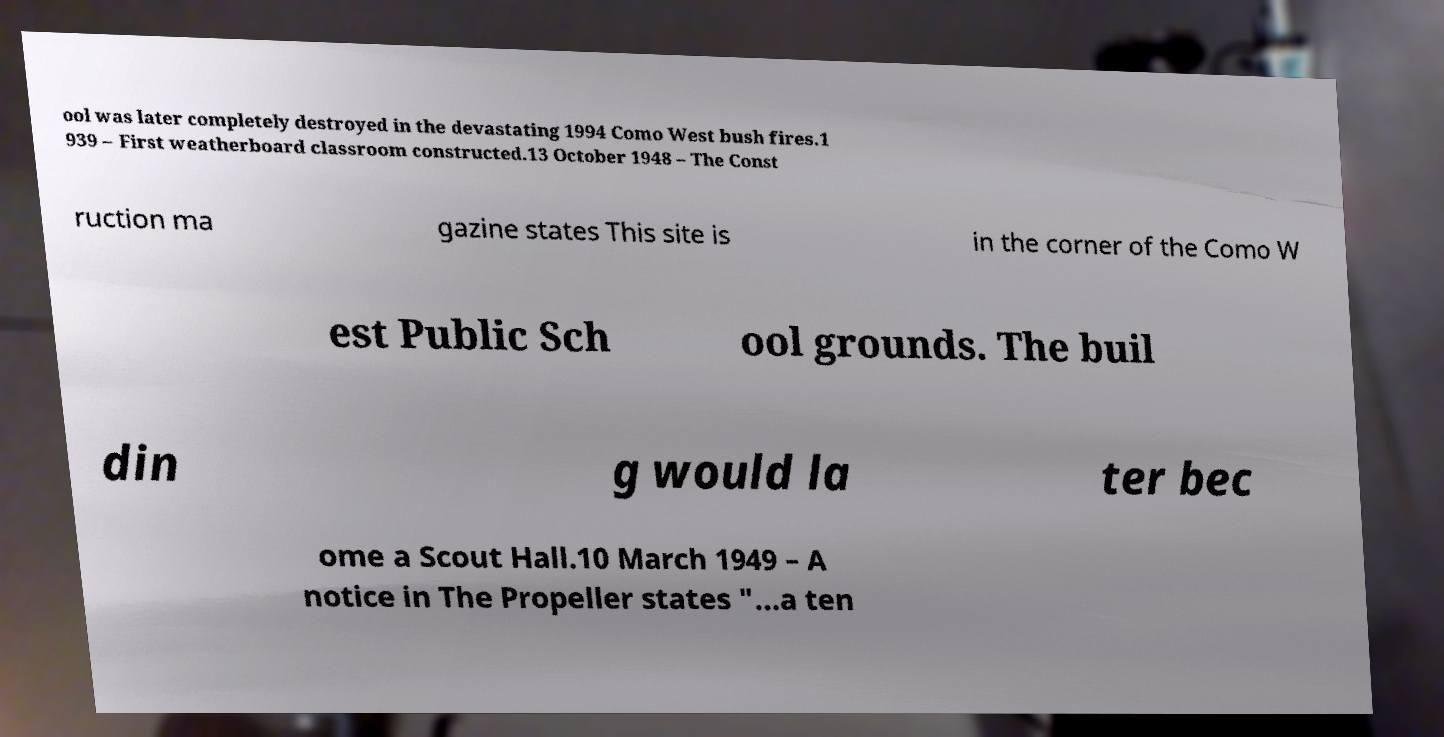Could you assist in decoding the text presented in this image and type it out clearly? ool was later completely destroyed in the devastating 1994 Como West bush fires.1 939 – First weatherboard classroom constructed.13 October 1948 – The Const ruction ma gazine states This site is in the corner of the Como W est Public Sch ool grounds. The buil din g would la ter bec ome a Scout Hall.10 March 1949 – A notice in The Propeller states "...a ten 